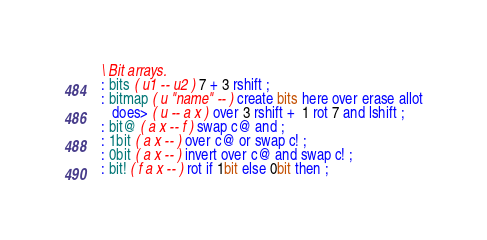Convert code to text. <code><loc_0><loc_0><loc_500><loc_500><_Forth_>\ Bit arrays.
: bits ( u1 -- u2 ) 7 + 3 rshift ;
: bitmap ( u "name" -- ) create bits here over erase allot
   does> ( u -- a x ) over 3 rshift +  1 rot 7 and lshift ;
: bit@ ( a x -- f ) swap c@ and ;
: 1bit ( a x -- ) over c@ or swap c! ;
: 0bit ( a x -- ) invert over c@ and swap c! ;
: bit! ( f a x -- ) rot if 1bit else 0bit then ;
</code> 